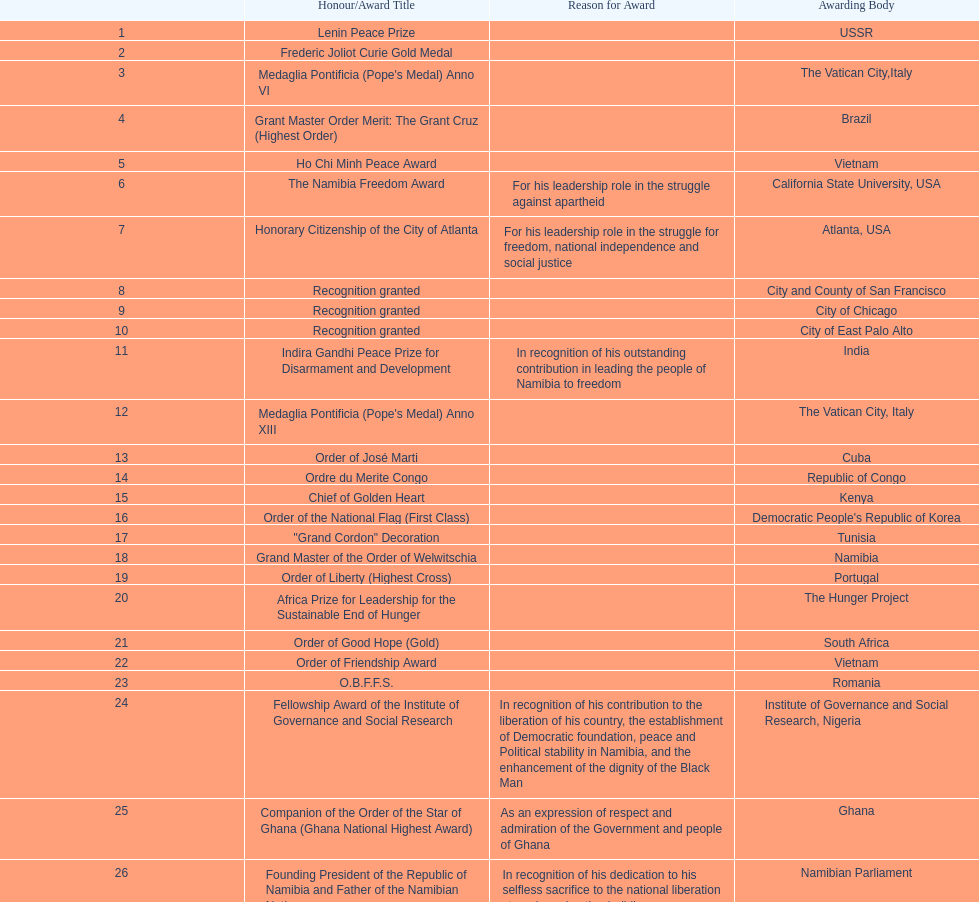What is the difference between the number of awards won in 1988 and the number of awards won in 1995? 4. 